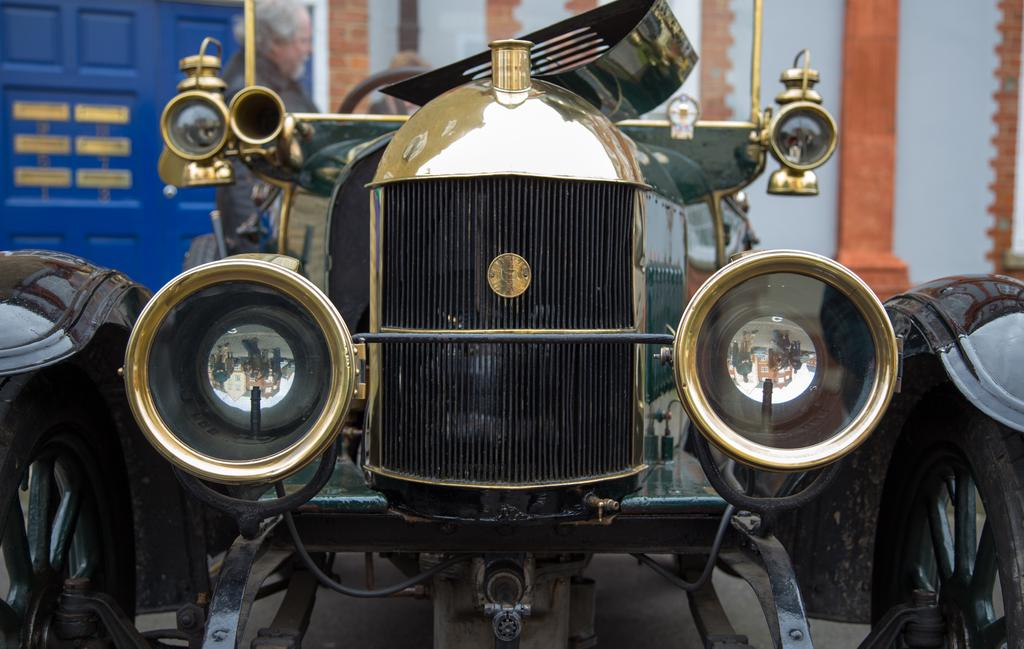What is the main subject of the image? The main subject of the image is a car. Can you describe the color of the car? The car is black and gold in color. Are there any people visible in the image? Yes, there is a person in the top left of the image. Can you tell me how many zebras are standing next to the car in the image? There are no zebras present in the image; it only features a car and a person. What sense is being used by the person in the image? The image does not provide information about the person's senses or actions, so it cannot be determined from the image. 